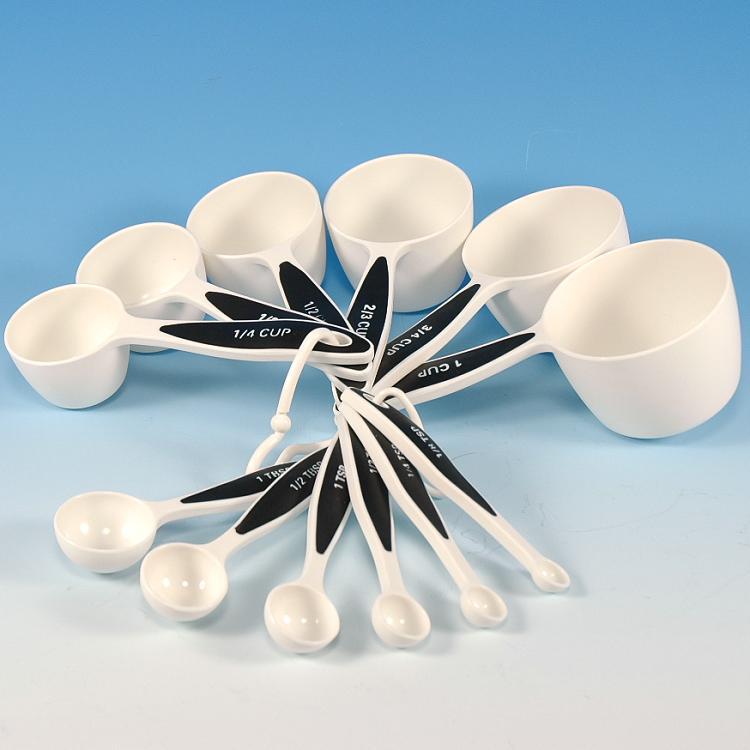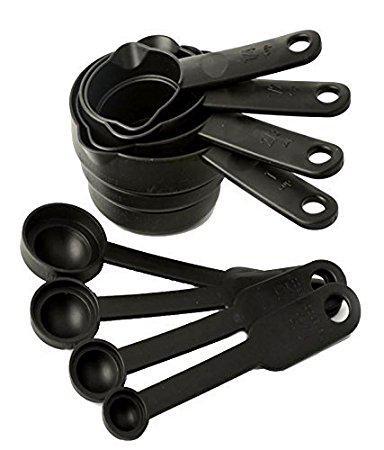The first image is the image on the left, the second image is the image on the right. Considering the images on both sides, is "Exactly two sets of measuring cups and spoons are fanned for display." valid? Answer yes or no. No. 